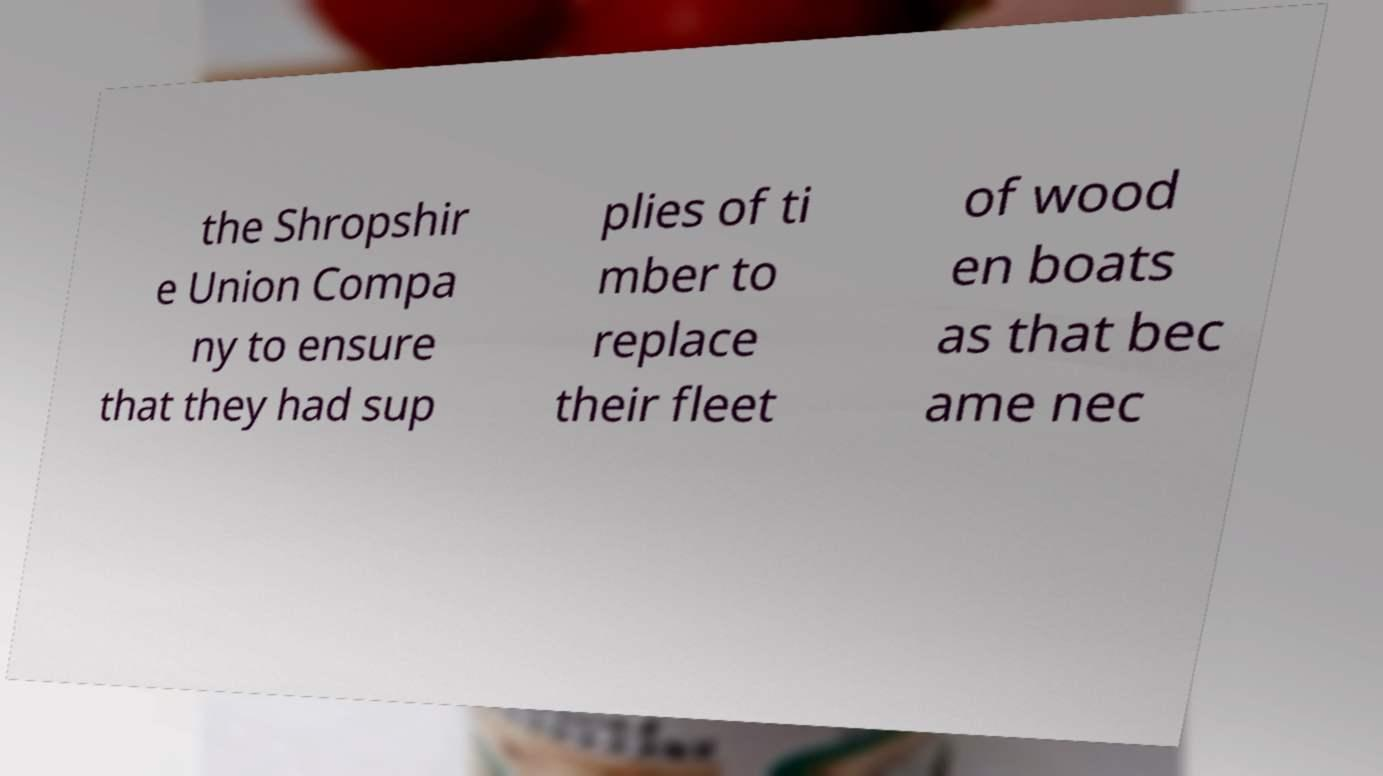Can you read and provide the text displayed in the image?This photo seems to have some interesting text. Can you extract and type it out for me? the Shropshir e Union Compa ny to ensure that they had sup plies of ti mber to replace their fleet of wood en boats as that bec ame nec 